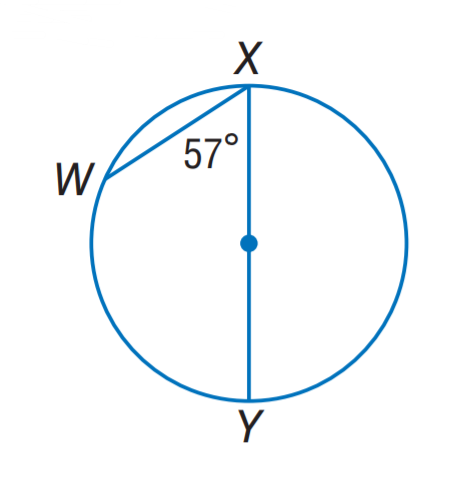Question: Find m \widehat W X.
Choices:
A. 57
B. 63
C. 66
D. 68
Answer with the letter. Answer: C 